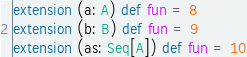Convert code to text. <code><loc_0><loc_0><loc_500><loc_500><_Scala_>
extension (a: A) def fun = 8
extension (b: B) def fun = 9
extension (as: Seq[A]) def fun = 10</code> 